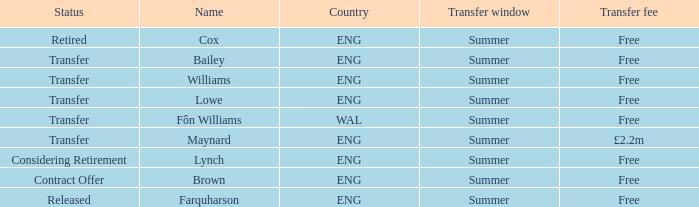What is the status of the ENG Country with the name of Farquharson? Released. 